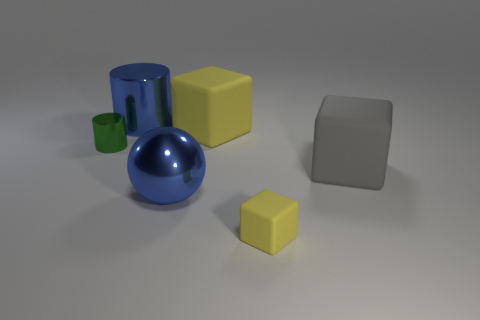Add 1 cyan rubber blocks. How many objects exist? 7 Subtract all balls. How many objects are left? 5 Add 5 gray matte cubes. How many gray matte cubes are left? 6 Add 6 small green metal cylinders. How many small green metal cylinders exist? 7 Subtract 0 brown cylinders. How many objects are left? 6 Subtract all big rubber balls. Subtract all gray blocks. How many objects are left? 5 